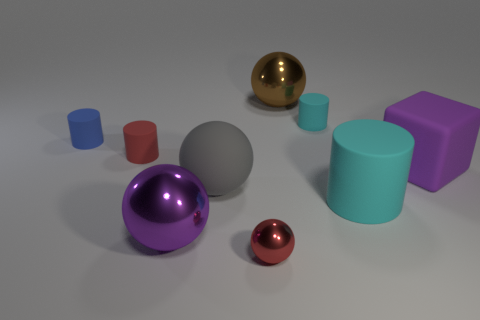Does the small sphere have the same color as the tiny cylinder in front of the blue matte thing?
Offer a terse response. Yes. Is the number of green things less than the number of rubber objects?
Offer a very short reply. Yes. There is a tiny red thing behind the purple ball; is its shape the same as the big brown shiny object?
Provide a succinct answer. No. Are any gray cubes visible?
Make the answer very short. No. There is a rubber object that is in front of the big rubber object left of the large thing behind the rubber block; what is its color?
Your answer should be very brief. Cyan. Is the number of red spheres that are behind the brown ball the same as the number of purple rubber cubes that are behind the matte block?
Provide a short and direct response. Yes. What is the shape of the cyan matte thing that is the same size as the blue matte thing?
Your answer should be very brief. Cylinder. Are there any metal spheres that have the same color as the small metallic thing?
Offer a very short reply. No. What is the shape of the big shiny object that is in front of the large purple matte block?
Offer a terse response. Sphere. What color is the tiny sphere?
Give a very brief answer. Red. 